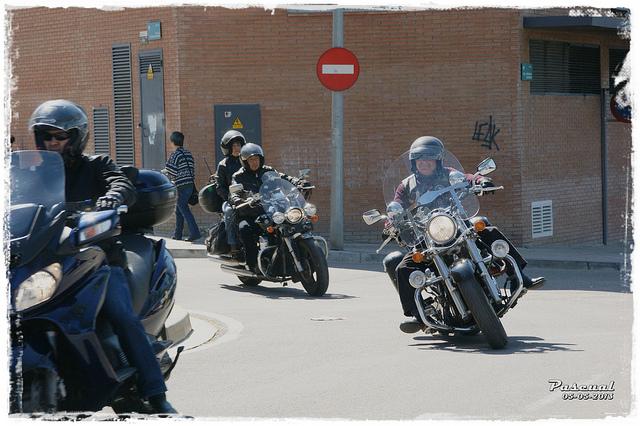Do both vehicles have headlights?
Keep it brief. Yes. What are the people driving?
Short answer required. Motorcycles. This guys are taking race or simply riding a bike?
Quick response, please. Riding. Are they driving fast?
Keep it brief. No. Where is there tagging on the wall?
Concise answer only. On right side. 